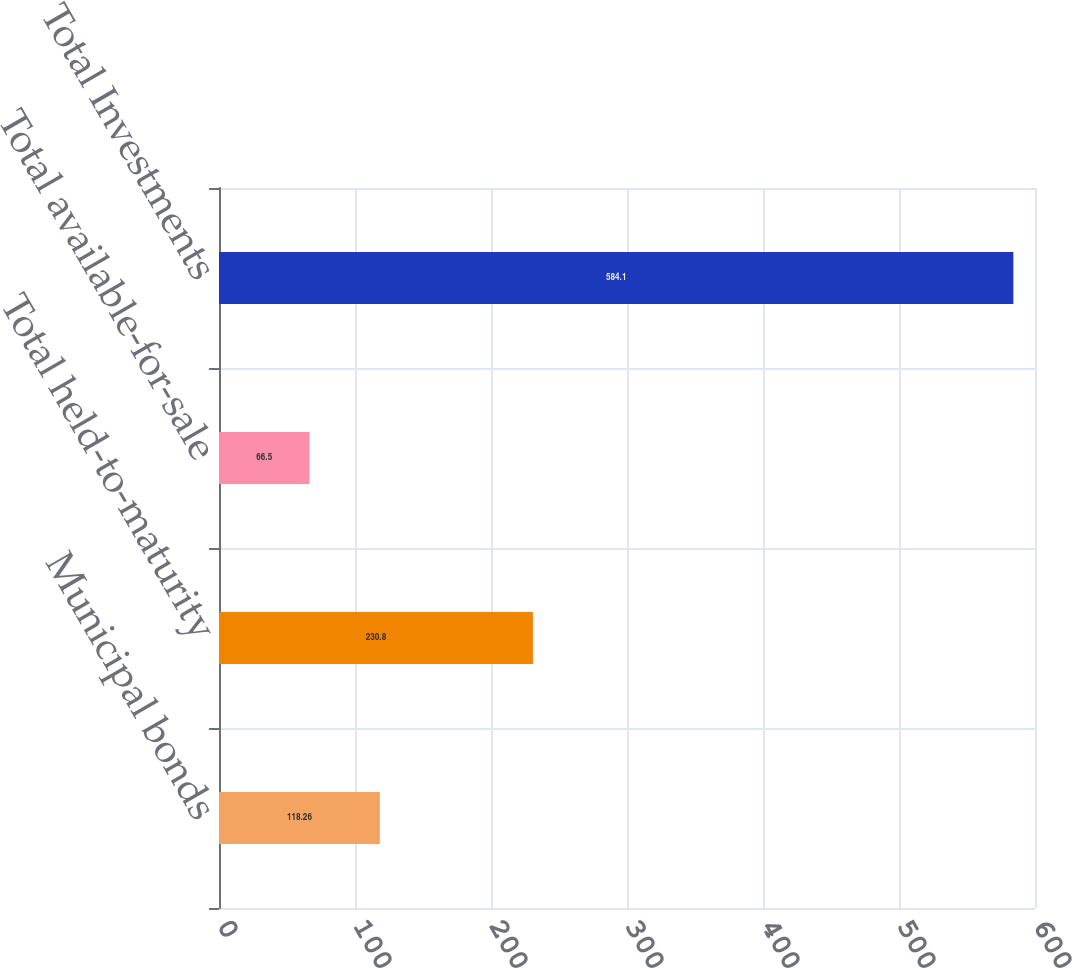Convert chart. <chart><loc_0><loc_0><loc_500><loc_500><bar_chart><fcel>Municipal bonds<fcel>Total held-to-maturity<fcel>Total available-for-sale<fcel>Total Investments<nl><fcel>118.26<fcel>230.8<fcel>66.5<fcel>584.1<nl></chart> 